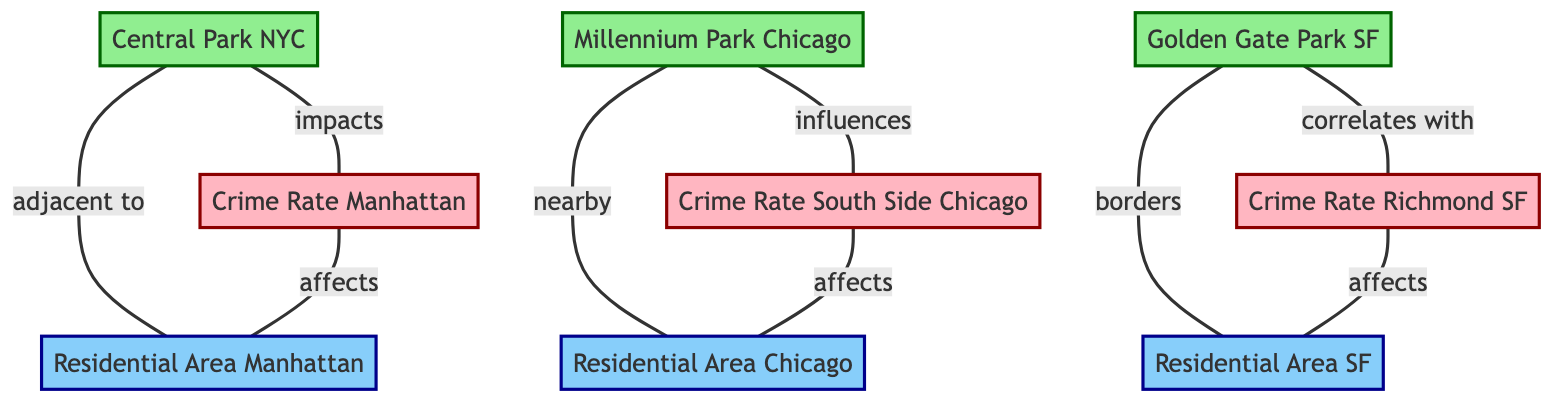What park is adjacent to Residential Area Manhattan? The edge labeled "adjacent to" connects Central Park NYC to Residential Area Manhattan, indicating that Central Park is the park in question.
Answer: Central Park NYC Which park correlates with Crime Rate Richmond SF? The diagram shows an edge labeled "correlates with" from Golden Gate Park SF to Crime Rate Richmond SF, indicating the correlation is with this specific park.
Answer: Golden Gate Park SF How many nodes are there in total? By counting the listed nodes, there are nine distinct nodes in the diagram representing parks, crime rates, and residential areas.
Answer: Nine Which residential area is affected by Crime Rate South Side Chicago? The edge labeled "affects" between Crime Rate South Side Chicago and Residential Area Chicago indicates that Residential Area Chicago is affected by this crime rate.
Answer: Residential Area Chicago What relationship is depicted between Millennium Park Chicago and Crime Rate South Side Chicago? The edge labeled "influences" shows the relationship from Millennium Park Chicago to Crime Rate South Side Chicago, indicating that Millennium Park has an influence on the crime rate in that area.
Answer: Influences What is the relationship between Golden Gate Park SF and Residential Area SF? The edge labeled "borders" connects Golden Gate Park SF to Residential Area SF, which indicates that Golden Gate Park is adjacent to or shares a boundary with the residential area.
Answer: Borders Which crime rate is impacted by Central Park NYC? The edge labeled "impacts" indicates that Central Park NYC is connected to Crime Rate Manhattan, meaning this crime rate is influenced by Central Park.
Answer: Crime Rate Manhattan How many edges are shown in the diagram? By counting the connections (or edges) listed between the nodes, there are eight edges illustrated in the diagram.
Answer: Eight Which park influences the crime rate in South Side Chicago? The edge labeled "influences" shows that Millennium Park Chicago affects Crime Rate South Side Chicago, indicating the specific park's influence.
Answer: Millennium Park Chicago 